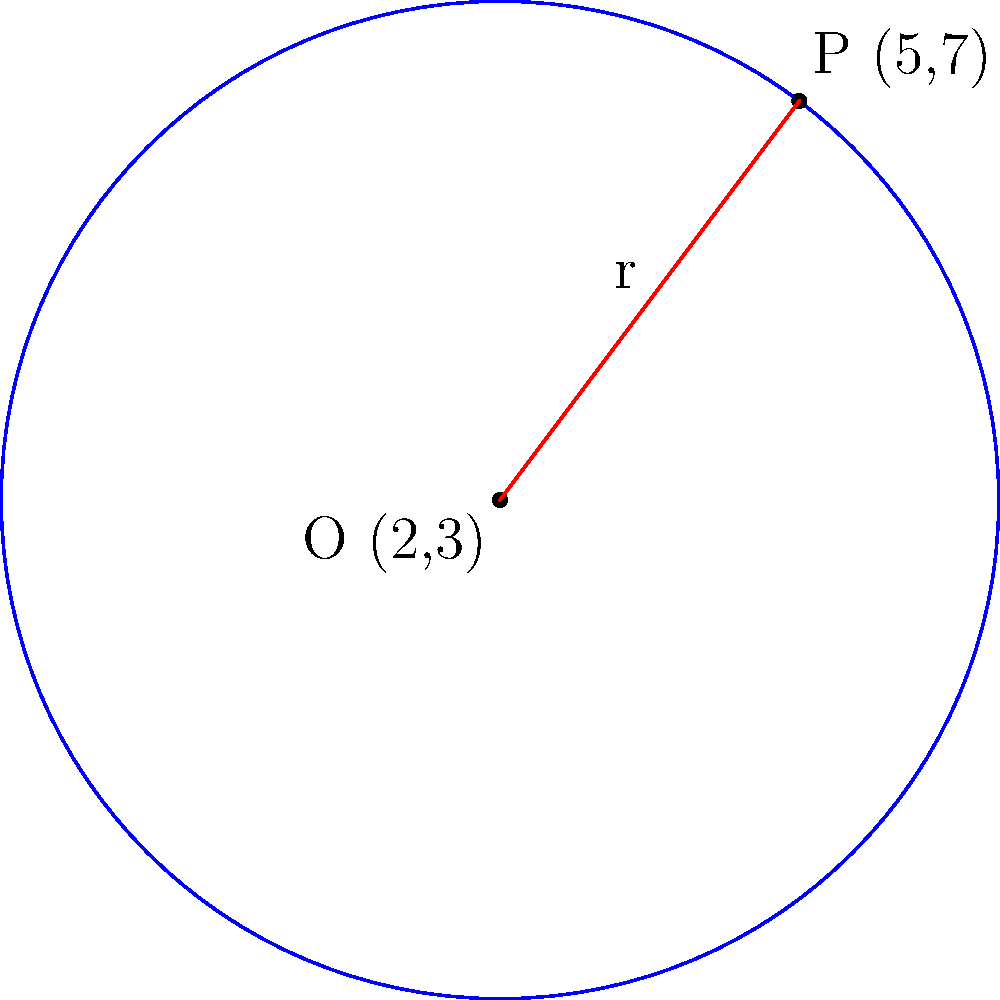In a landmark case, you successfully argued for equal representation in a major law firm. To celebrate, your team decides to create a circular logo. The center of the logo is placed at coordinates (2,3), representing the firm's founding year, and a point on its circumference is at (5,7), symbolizing the year of your groundbreaking case. Determine the equation of this circle that will become your firm's new emblem. Let's approach this step-by-step:

1) The general equation of a circle is $$(x-h)^2 + (y-k)^2 = r^2$$
   where $(h,k)$ is the center and $r$ is the radius.

2) We're given the center (2,3), so $h=2$ and $k=3$.

3) To find $r$, we can use the distance formula between the center and the point on the circumference:

   $$r = \sqrt{(x_2-x_1)^2 + (y_2-y_1)^2}$$
   $$r = \sqrt{(5-2)^2 + (7-3)^2}$$
   $$r = \sqrt{3^2 + 4^2}$$
   $$r = \sqrt{9 + 16}$$
   $$r = \sqrt{25} = 5$$

4) Now we can substitute these values into the general equation:

   $$(x-2)^2 + (y-3)^2 = 5^2$$

5) Simplify:

   $$(x-2)^2 + (y-3)^2 = 25$$

This is the equation of the circle representing your firm's new logo.
Answer: $(x-2)^2 + (y-3)^2 = 25$ 